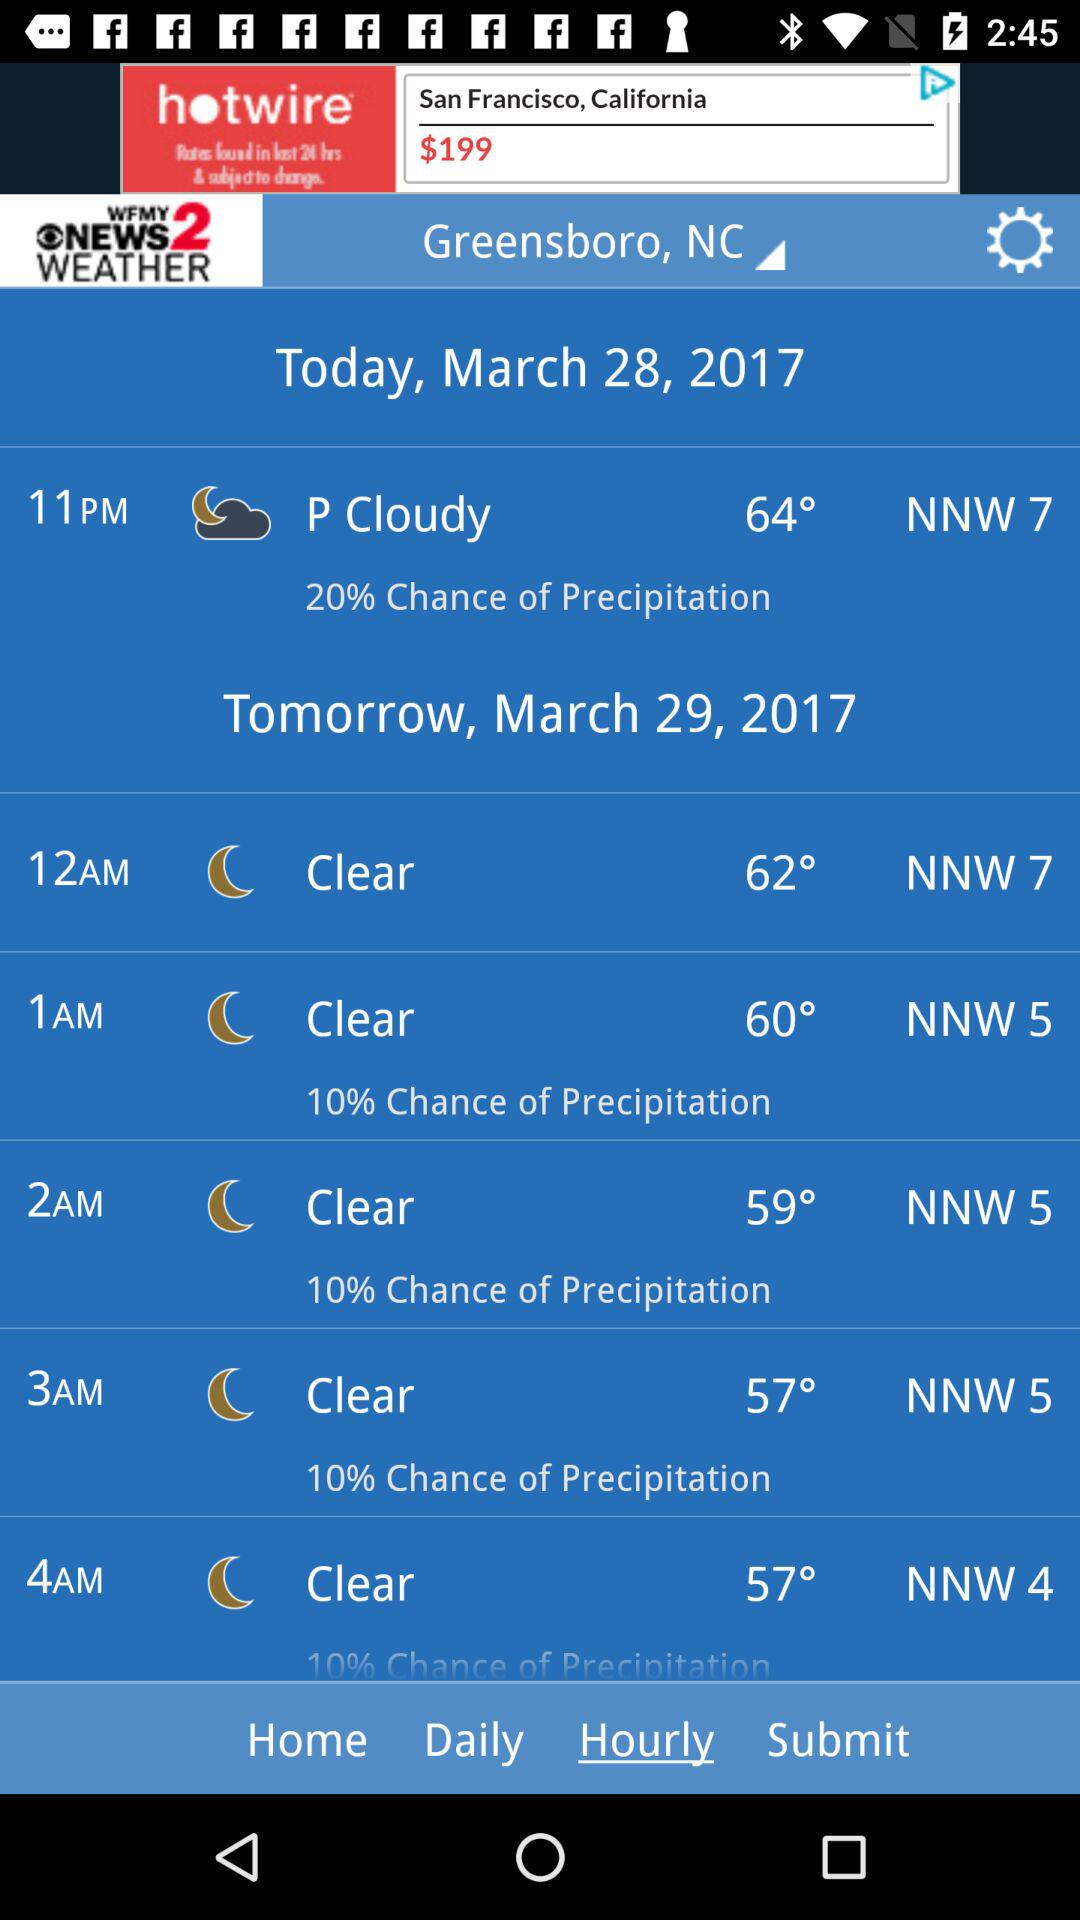What is the minimum temperature for tomorrow?
Answer the question using a single word or phrase. 57° 